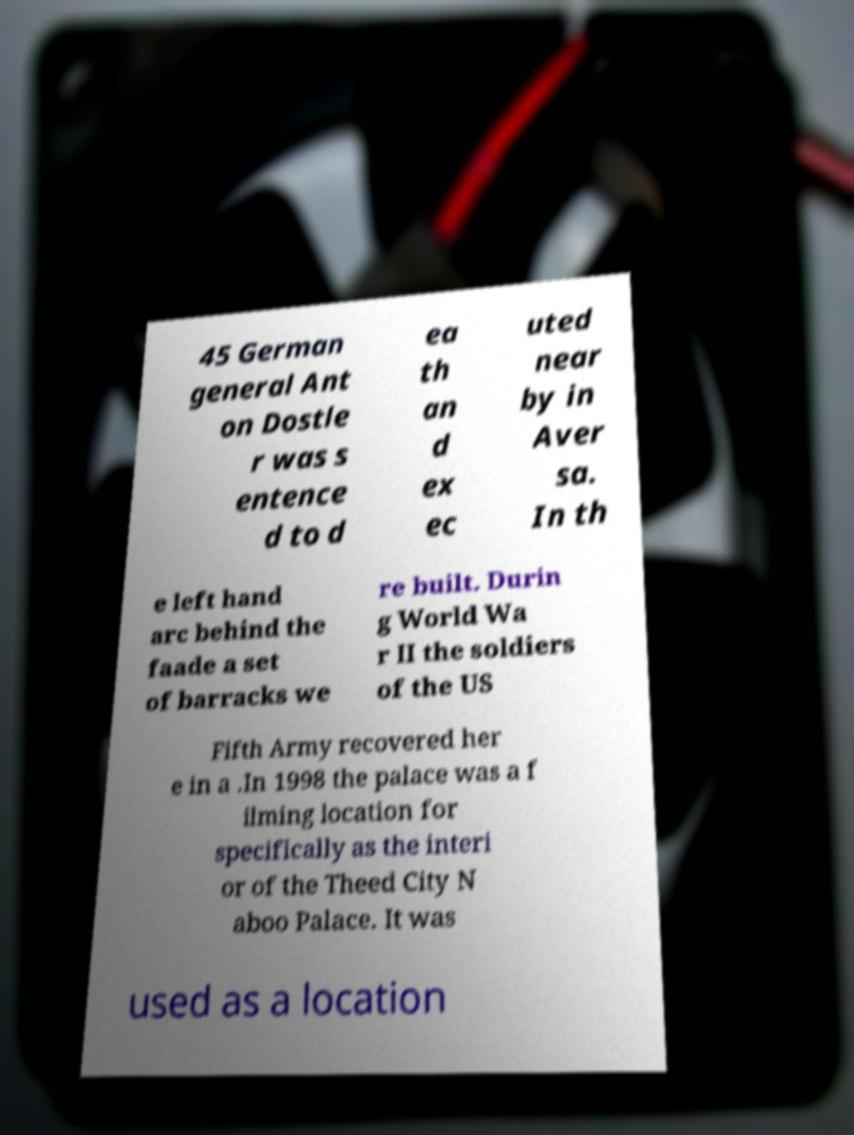Could you extract and type out the text from this image? 45 German general Ant on Dostle r was s entence d to d ea th an d ex ec uted near by in Aver sa. In th e left hand arc behind the faade a set of barracks we re built. Durin g World Wa r II the soldiers of the US Fifth Army recovered her e in a .In 1998 the palace was a f ilming location for specifically as the interi or of the Theed City N aboo Palace. It was used as a location 